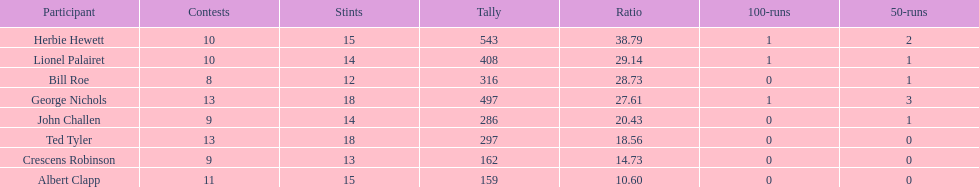Name a player whose average was above 25. Herbie Hewett. 